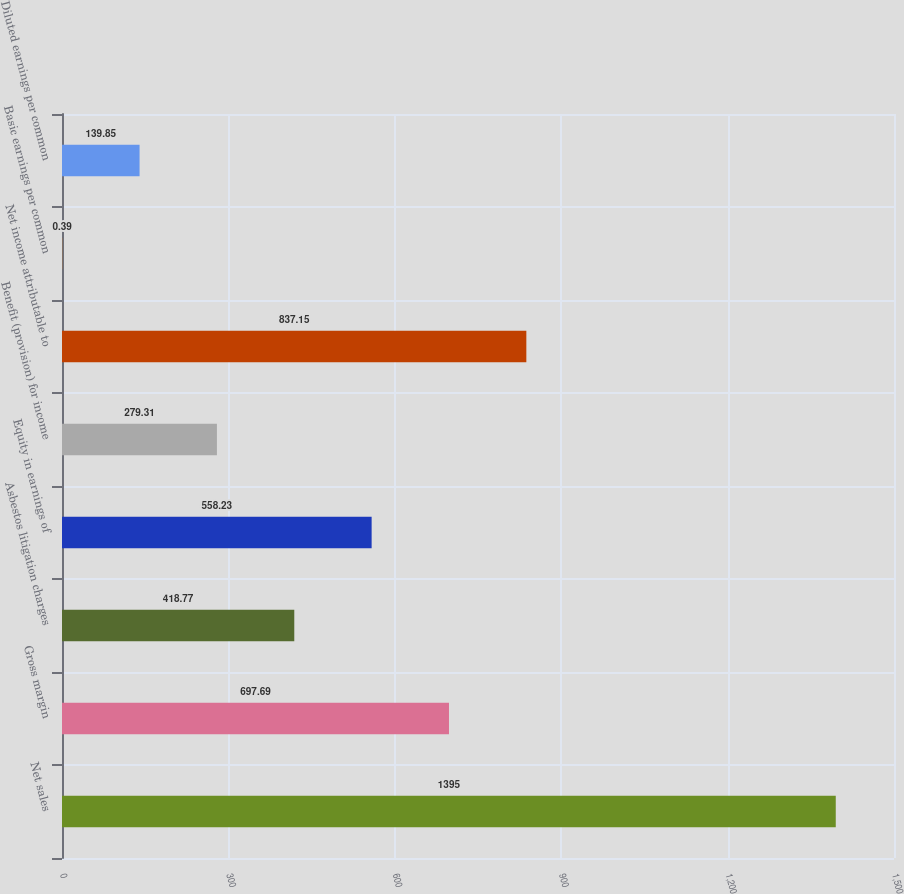Convert chart to OTSL. <chart><loc_0><loc_0><loc_500><loc_500><bar_chart><fcel>Net sales<fcel>Gross margin<fcel>Asbestos litigation charges<fcel>Equity in earnings of<fcel>Benefit (provision) for income<fcel>Net income attributable to<fcel>Basic earnings per common<fcel>Diluted earnings per common<nl><fcel>1395<fcel>697.69<fcel>418.77<fcel>558.23<fcel>279.31<fcel>837.15<fcel>0.39<fcel>139.85<nl></chart> 